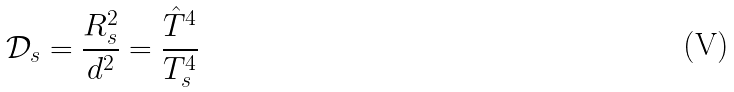Convert formula to latex. <formula><loc_0><loc_0><loc_500><loc_500>\mathcal { D } _ { s } = \frac { R _ { s } ^ { 2 } } { d ^ { 2 } } = \frac { \hat { T } ^ { 4 } } { T _ { s } ^ { 4 } }</formula> 